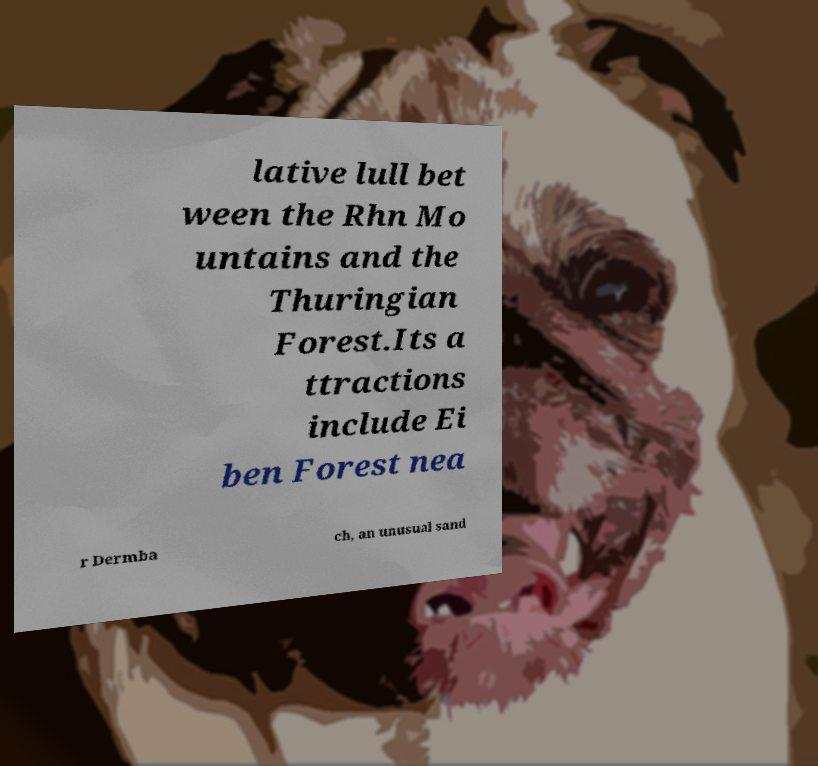Please read and relay the text visible in this image. What does it say? lative lull bet ween the Rhn Mo untains and the Thuringian Forest.Its a ttractions include Ei ben Forest nea r Dermba ch, an unusual sand 